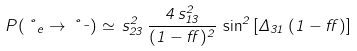Convert formula to latex. <formula><loc_0><loc_0><loc_500><loc_500>P ( \nu _ { e } \rightarrow \nu _ { \mu } ) \simeq \, s ^ { 2 } _ { 2 3 } \, \frac { 4 \, s ^ { 2 } _ { 1 3 } } { ( 1 - \alpha ) ^ { 2 } } \, \sin ^ { 2 } { [ \Delta _ { 3 1 } \, ( 1 - \alpha ) ] }</formula> 